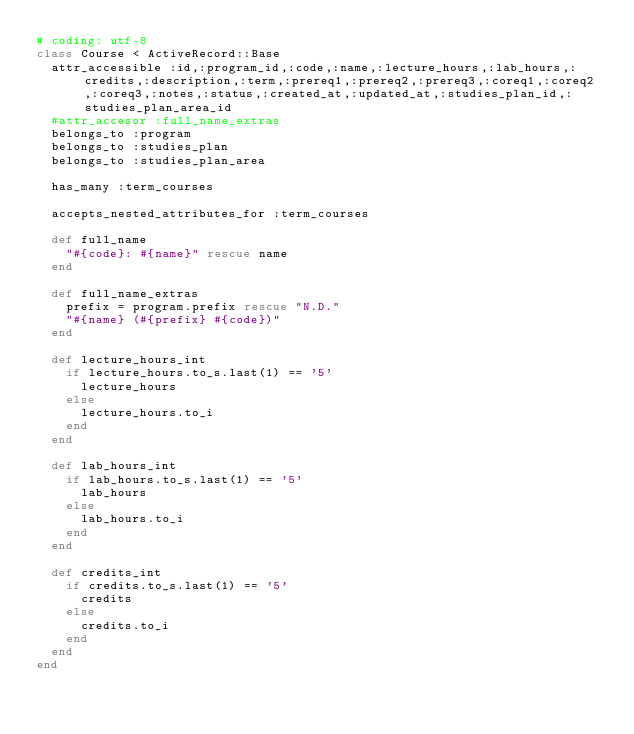Convert code to text. <code><loc_0><loc_0><loc_500><loc_500><_Ruby_># coding: utf-8
class Course < ActiveRecord::Base
  attr_accessible :id,:program_id,:code,:name,:lecture_hours,:lab_hours,:credits,:description,:term,:prereq1,:prereq2,:prereq3,:coreq1,:coreq2,:coreq3,:notes,:status,:created_at,:updated_at,:studies_plan_id,:studies_plan_area_id
  #attr_accesor :full_name_extras
  belongs_to :program
  belongs_to :studies_plan
  belongs_to :studies_plan_area

  has_many :term_courses

  accepts_nested_attributes_for :term_courses

  def full_name
    "#{code}: #{name}" rescue name
  end

  def full_name_extras
    prefix = program.prefix rescue "N.D."
    "#{name} (#{prefix} #{code})"
  end

  def lecture_hours_int
    if lecture_hours.to_s.last(1) == '5'
      lecture_hours
    else 
      lecture_hours.to_i
    end
  end 

  def lab_hours_int
    if lab_hours.to_s.last(1) == '5'
      lab_hours
    else 
      lab_hours.to_i
    end
  end

  def credits_int
    if credits.to_s.last(1) == '5'
      credits
    else 
      credits.to_i
    end
  end
end
</code> 